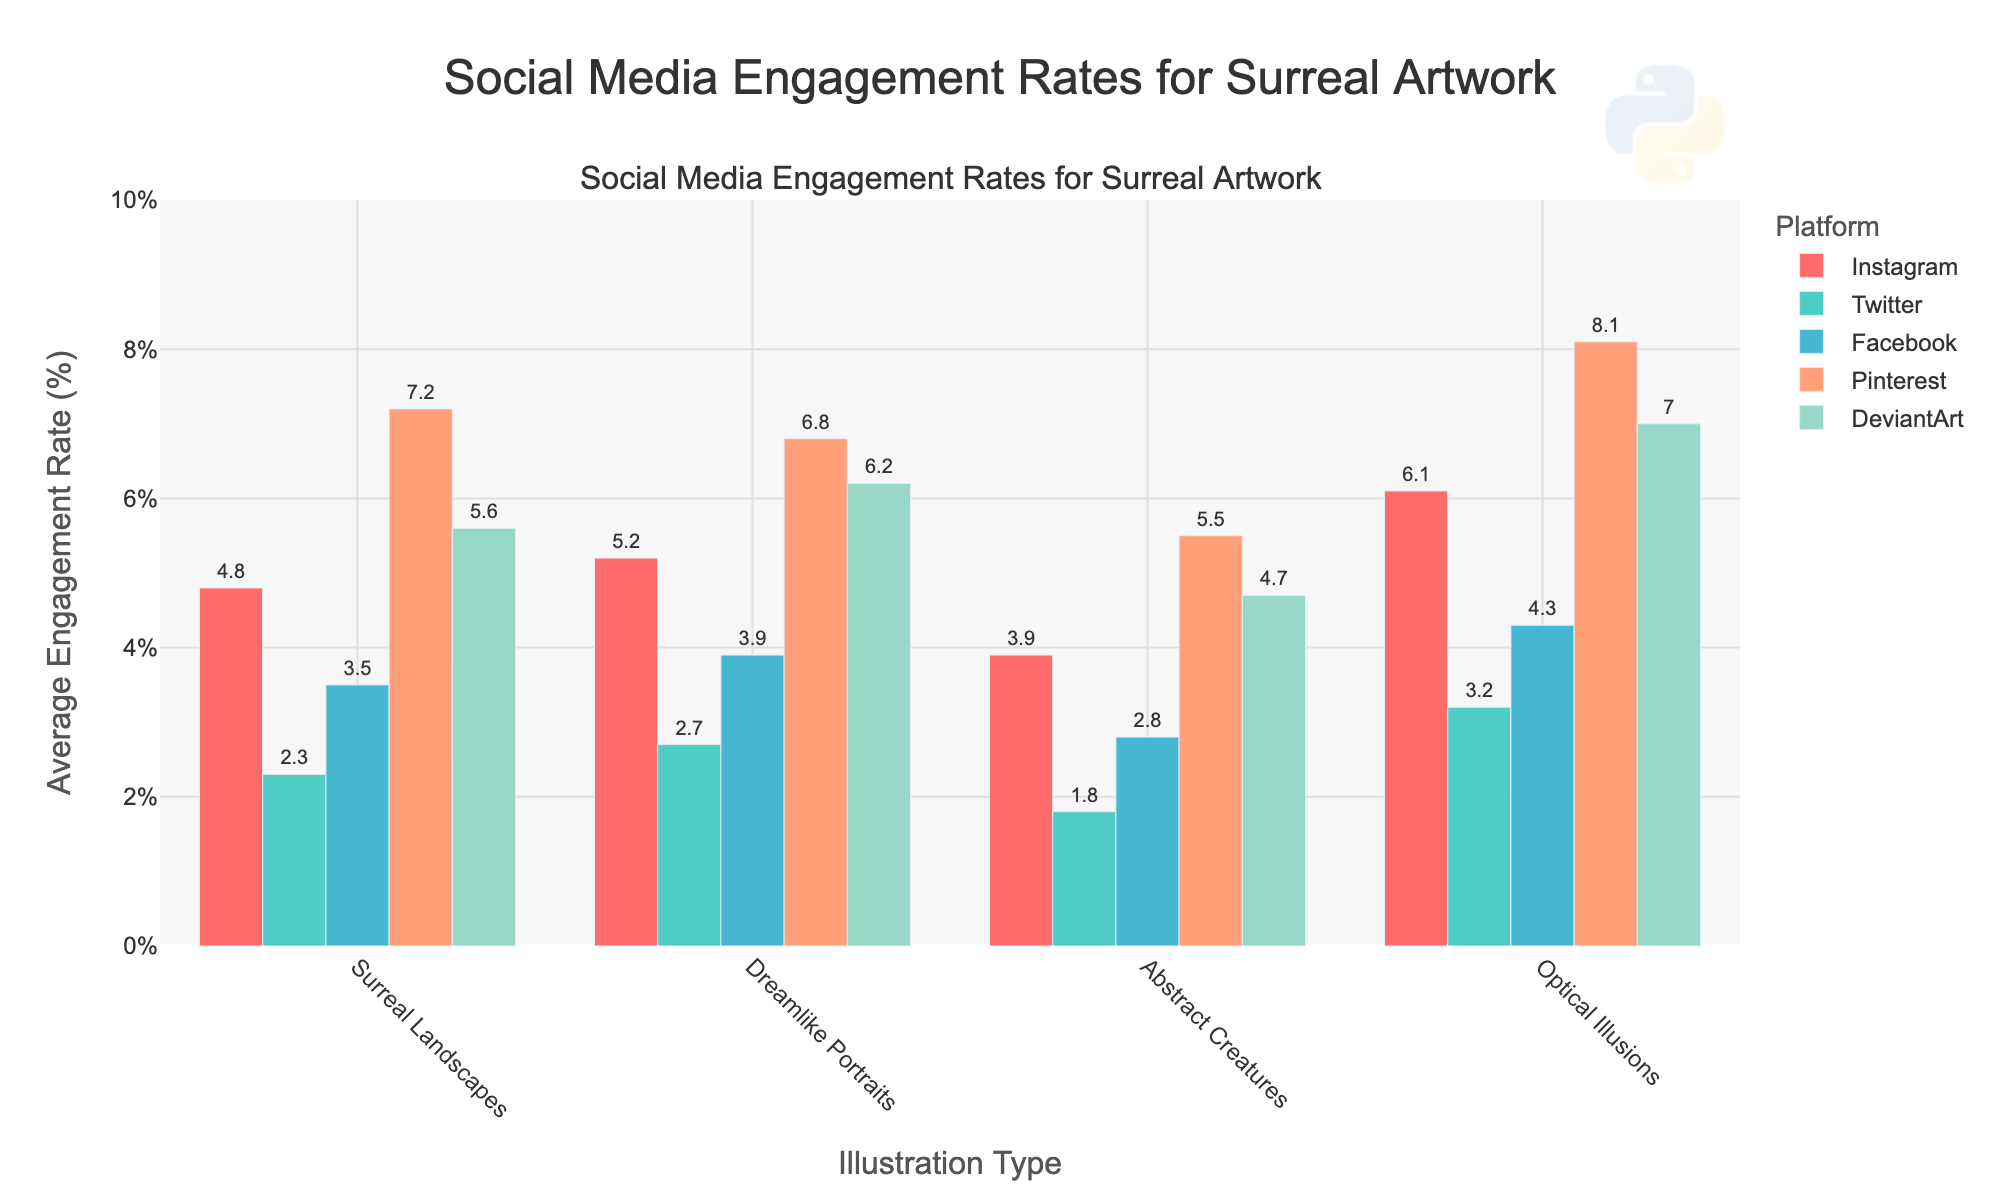Which platform has the highest average engagement rate for 'Optical Illusions'? To find the answer, look at the bars representing 'Optical Illusions' on each platform. The tallest bar represents the platform with the highest engagement rate.
Answer: Pinterest Compare the average engagement rates for 'Dreamlike Portraits' between Instagram and Twitter. Which one is higher? Look at the heights of the bars for 'Dreamlike Portraits' on Instagram and Twitter. The platform with the taller bar has the higher average engagement rate.
Answer: Instagram What's the combined average engagement rate of 'Abstract Creatures' on Facebook and DeviantArt? Add the average engagement rates for 'Abstract Creatures' on Facebook and DeviantArt. The rates are 2.8% and 4.7% respectively. 2.8 + 4.7 = 7.5
Answer: 7.5% What is the average engagement rate for 'Surreal Landscapes' across all platforms? Sum the engagement rates for 'Surreal Landscapes' across all platforms and divide by the number of platforms. The rates are 4.8 (Instagram) + 2.3 (Twitter) + 3.5 (Facebook) + 7.2 (Pinterest) + 5.6 (DeviantArt). Total = 23.4, divide by 5 = 4.68
Answer: 4.68% Which illustration type on Instagram has the lowest engagement rate? Identify the illustration type with the shortest bar on Instagram.
Answer: Abstract Creatures How much greater is DeviantArt's engagement rate for 'Optical Illusions' compared to Twitter's engagement rate for the same illustration type? Substract Twitter’s engagement rate for 'Optical Illusions' from DeviantArt’s engagement rate for the same type. 7.0% - 3.2% = 3.8%
Answer: 3.8% Which platform shows the smallest engagement rate for any type of illustration? Find the shortest bar across all platforms and all types of illustrations.
Answer: Twitter On which platform do 'Dreamlike Portraits' posts have the highest engagement rate? Look for the tallest bar representing 'Dreamlike Portraits' across all platforms.
Answer: Instagram Arrange the platforms in descending order of their engagement rates for 'Optical Illusions'. Compare the heights of all bars representing 'Optical Illusions' and arrange them from tallest to shortest. Order: Pinterest (8.1%), DeviantArt (7.0%), Instagram (6.1%), Facebook (4.3%), Twitter (3.2%)
Answer: Pinterest > DeviantArt > Instagram > Facebook > Twitter 